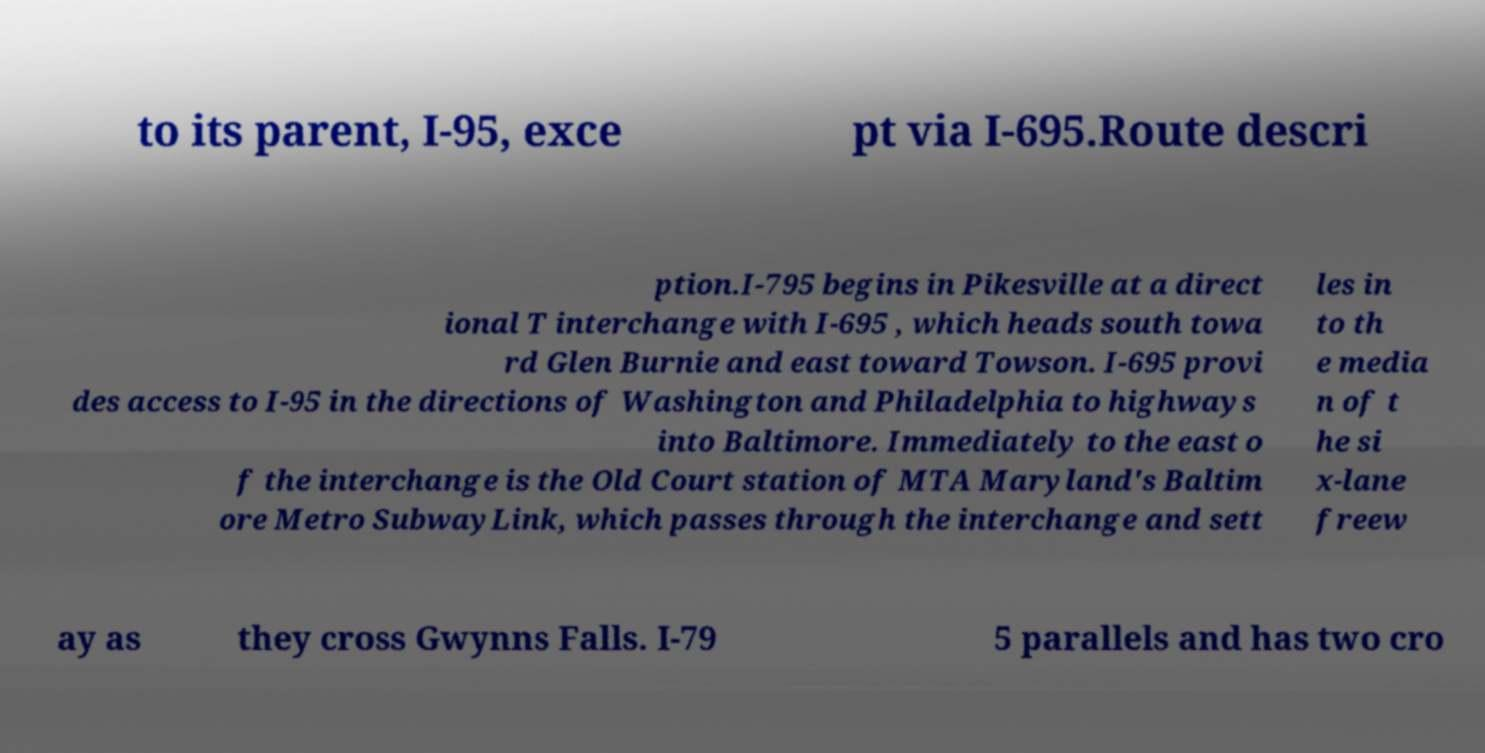Please identify and transcribe the text found in this image. to its parent, I-95, exce pt via I-695.Route descri ption.I-795 begins in Pikesville at a direct ional T interchange with I-695 , which heads south towa rd Glen Burnie and east toward Towson. I-695 provi des access to I-95 in the directions of Washington and Philadelphia to highways into Baltimore. Immediately to the east o f the interchange is the Old Court station of MTA Maryland's Baltim ore Metro SubwayLink, which passes through the interchange and sett les in to th e media n of t he si x-lane freew ay as they cross Gwynns Falls. I-79 5 parallels and has two cro 